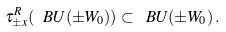<formula> <loc_0><loc_0><loc_500><loc_500>\tau ^ { R } _ { \pm x } ( \ B U ( \pm W _ { 0 } ) ) \subset \ B U ( \pm W _ { 0 } ) \, .</formula> 